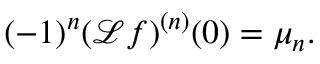Convert formula to latex. <formula><loc_0><loc_0><loc_500><loc_500>( - 1 ) ^ { n } ( { \mathcal { L } } f ) ^ { ( n ) } ( 0 ) = \mu _ { n } .</formula> 